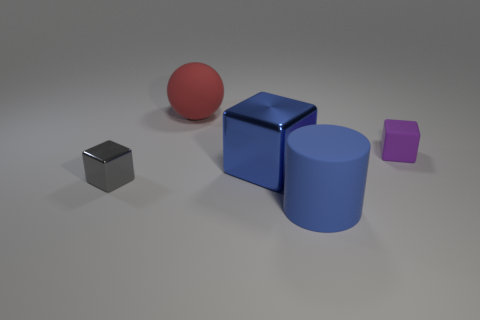What could be the potential use of these objects if they were real? If these objects were real, they could serve various purposes. The small cubes could be weights for a scale or decorative objects. The large blue cube and cylinder might be furniture pieces or part of a playground structure. The red sphere might be a ball for recreational activities. Their uses are as diverse as one's imagination. 